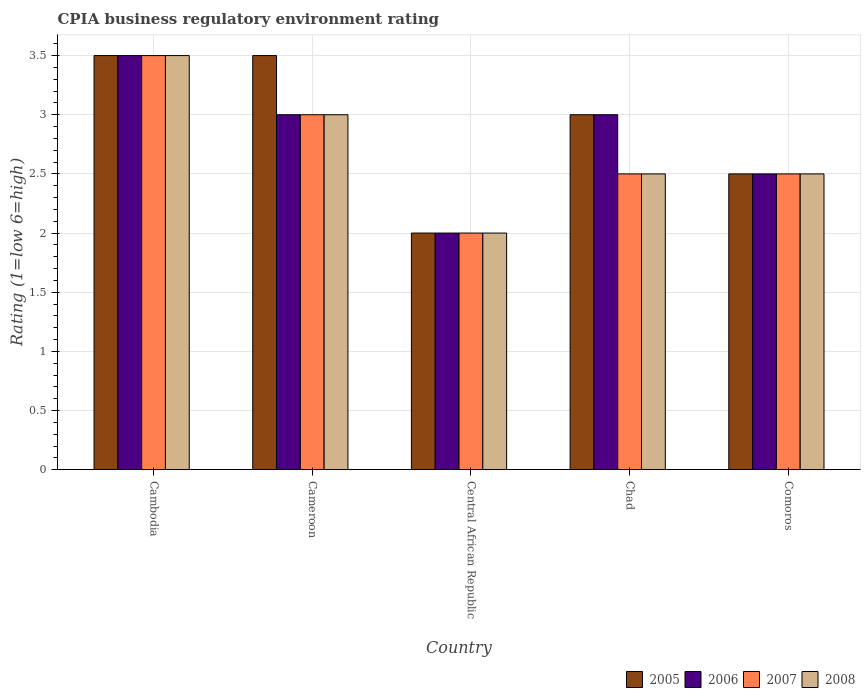How many different coloured bars are there?
Offer a terse response. 4. What is the label of the 4th group of bars from the left?
Your answer should be very brief. Chad. In which country was the CPIA rating in 2008 maximum?
Keep it short and to the point. Cambodia. In which country was the CPIA rating in 2008 minimum?
Keep it short and to the point. Central African Republic. What is the difference between the CPIA rating in 2006 in Cambodia and the CPIA rating in 2008 in Cameroon?
Keep it short and to the point. 0.5. What is the difference between the CPIA rating of/in 2007 and CPIA rating of/in 2005 in Cameroon?
Provide a succinct answer. -0.5. What is the ratio of the CPIA rating in 2007 in Cambodia to that in Central African Republic?
Your answer should be compact. 1.75. Is the CPIA rating in 2006 in Cambodia less than that in Chad?
Offer a very short reply. No. Is the difference between the CPIA rating in 2007 in Cameroon and Comoros greater than the difference between the CPIA rating in 2005 in Cameroon and Comoros?
Keep it short and to the point. No. What is the difference between the highest and the second highest CPIA rating in 2005?
Provide a succinct answer. -0.5. What is the difference between the highest and the lowest CPIA rating in 2007?
Your response must be concise. 1.5. In how many countries, is the CPIA rating in 2007 greater than the average CPIA rating in 2007 taken over all countries?
Provide a succinct answer. 2. Is the sum of the CPIA rating in 2008 in Cambodia and Central African Republic greater than the maximum CPIA rating in 2005 across all countries?
Give a very brief answer. Yes. Is it the case that in every country, the sum of the CPIA rating in 2005 and CPIA rating in 2007 is greater than the sum of CPIA rating in 2006 and CPIA rating in 2008?
Ensure brevity in your answer.  No. What does the 2nd bar from the left in Central African Republic represents?
Your answer should be compact. 2006. What does the 4th bar from the right in Cameroon represents?
Your response must be concise. 2005. Is it the case that in every country, the sum of the CPIA rating in 2007 and CPIA rating in 2008 is greater than the CPIA rating in 2006?
Keep it short and to the point. Yes. Are all the bars in the graph horizontal?
Ensure brevity in your answer.  No. What is the difference between two consecutive major ticks on the Y-axis?
Offer a terse response. 0.5. Are the values on the major ticks of Y-axis written in scientific E-notation?
Make the answer very short. No. Does the graph contain grids?
Offer a very short reply. Yes. Where does the legend appear in the graph?
Your answer should be very brief. Bottom right. How many legend labels are there?
Give a very brief answer. 4. How are the legend labels stacked?
Make the answer very short. Horizontal. What is the title of the graph?
Provide a short and direct response. CPIA business regulatory environment rating. Does "1996" appear as one of the legend labels in the graph?
Ensure brevity in your answer.  No. What is the label or title of the X-axis?
Give a very brief answer. Country. What is the label or title of the Y-axis?
Ensure brevity in your answer.  Rating (1=low 6=high). What is the Rating (1=low 6=high) of 2006 in Cameroon?
Your answer should be compact. 3. What is the Rating (1=low 6=high) in 2007 in Cameroon?
Provide a short and direct response. 3. What is the Rating (1=low 6=high) of 2007 in Central African Republic?
Your answer should be very brief. 2. What is the Rating (1=low 6=high) of 2008 in Central African Republic?
Provide a short and direct response. 2. What is the Rating (1=low 6=high) of 2005 in Chad?
Your response must be concise. 3. What is the Rating (1=low 6=high) in 2008 in Chad?
Provide a succinct answer. 2.5. What is the Rating (1=low 6=high) of 2006 in Comoros?
Provide a short and direct response. 2.5. What is the Rating (1=low 6=high) of 2007 in Comoros?
Offer a very short reply. 2.5. Across all countries, what is the minimum Rating (1=low 6=high) of 2005?
Your response must be concise. 2. What is the total Rating (1=low 6=high) of 2005 in the graph?
Give a very brief answer. 14.5. What is the total Rating (1=low 6=high) in 2006 in the graph?
Offer a very short reply. 14. What is the total Rating (1=low 6=high) of 2008 in the graph?
Make the answer very short. 13.5. What is the difference between the Rating (1=low 6=high) of 2005 in Cambodia and that in Cameroon?
Provide a succinct answer. 0. What is the difference between the Rating (1=low 6=high) in 2008 in Cambodia and that in Cameroon?
Keep it short and to the point. 0.5. What is the difference between the Rating (1=low 6=high) of 2005 in Cambodia and that in Central African Republic?
Offer a terse response. 1.5. What is the difference between the Rating (1=low 6=high) of 2007 in Cambodia and that in Central African Republic?
Offer a terse response. 1.5. What is the difference between the Rating (1=low 6=high) of 2008 in Cambodia and that in Central African Republic?
Give a very brief answer. 1.5. What is the difference between the Rating (1=low 6=high) of 2005 in Cambodia and that in Chad?
Provide a succinct answer. 0.5. What is the difference between the Rating (1=low 6=high) in 2006 in Cambodia and that in Chad?
Make the answer very short. 0.5. What is the difference between the Rating (1=low 6=high) of 2008 in Cambodia and that in Chad?
Give a very brief answer. 1. What is the difference between the Rating (1=low 6=high) in 2005 in Cambodia and that in Comoros?
Your answer should be compact. 1. What is the difference between the Rating (1=low 6=high) of 2006 in Cambodia and that in Comoros?
Ensure brevity in your answer.  1. What is the difference between the Rating (1=low 6=high) of 2007 in Cambodia and that in Comoros?
Your answer should be compact. 1. What is the difference between the Rating (1=low 6=high) in 2008 in Cambodia and that in Comoros?
Make the answer very short. 1. What is the difference between the Rating (1=low 6=high) of 2006 in Cameroon and that in Central African Republic?
Make the answer very short. 1. What is the difference between the Rating (1=low 6=high) of 2005 in Cameroon and that in Chad?
Offer a very short reply. 0.5. What is the difference between the Rating (1=low 6=high) of 2007 in Cameroon and that in Chad?
Make the answer very short. 0.5. What is the difference between the Rating (1=low 6=high) in 2008 in Cameroon and that in Chad?
Ensure brevity in your answer.  0.5. What is the difference between the Rating (1=low 6=high) of 2006 in Cameroon and that in Comoros?
Provide a short and direct response. 0.5. What is the difference between the Rating (1=low 6=high) of 2007 in Cameroon and that in Comoros?
Your response must be concise. 0.5. What is the difference between the Rating (1=low 6=high) in 2006 in Central African Republic and that in Chad?
Your answer should be compact. -1. What is the difference between the Rating (1=low 6=high) of 2007 in Central African Republic and that in Chad?
Give a very brief answer. -0.5. What is the difference between the Rating (1=low 6=high) of 2005 in Central African Republic and that in Comoros?
Your response must be concise. -0.5. What is the difference between the Rating (1=low 6=high) in 2008 in Central African Republic and that in Comoros?
Your response must be concise. -0.5. What is the difference between the Rating (1=low 6=high) in 2005 in Chad and that in Comoros?
Make the answer very short. 0.5. What is the difference between the Rating (1=low 6=high) in 2008 in Chad and that in Comoros?
Offer a very short reply. 0. What is the difference between the Rating (1=low 6=high) in 2005 in Cambodia and the Rating (1=low 6=high) in 2007 in Cameroon?
Offer a terse response. 0.5. What is the difference between the Rating (1=low 6=high) of 2006 in Cambodia and the Rating (1=low 6=high) of 2007 in Cameroon?
Provide a succinct answer. 0.5. What is the difference between the Rating (1=low 6=high) of 2007 in Cambodia and the Rating (1=low 6=high) of 2008 in Cameroon?
Your response must be concise. 0.5. What is the difference between the Rating (1=low 6=high) in 2005 in Cambodia and the Rating (1=low 6=high) in 2006 in Central African Republic?
Offer a terse response. 1.5. What is the difference between the Rating (1=low 6=high) in 2005 in Cambodia and the Rating (1=low 6=high) in 2008 in Central African Republic?
Make the answer very short. 1.5. What is the difference between the Rating (1=low 6=high) in 2007 in Cambodia and the Rating (1=low 6=high) in 2008 in Central African Republic?
Offer a very short reply. 1.5. What is the difference between the Rating (1=low 6=high) in 2005 in Cambodia and the Rating (1=low 6=high) in 2008 in Chad?
Offer a very short reply. 1. What is the difference between the Rating (1=low 6=high) of 2006 in Cambodia and the Rating (1=low 6=high) of 2007 in Chad?
Offer a very short reply. 1. What is the difference between the Rating (1=low 6=high) of 2007 in Cambodia and the Rating (1=low 6=high) of 2008 in Chad?
Provide a short and direct response. 1. What is the difference between the Rating (1=low 6=high) in 2005 in Cambodia and the Rating (1=low 6=high) in 2007 in Comoros?
Keep it short and to the point. 1. What is the difference between the Rating (1=low 6=high) of 2006 in Cambodia and the Rating (1=low 6=high) of 2007 in Comoros?
Make the answer very short. 1. What is the difference between the Rating (1=low 6=high) in 2006 in Cameroon and the Rating (1=low 6=high) in 2008 in Central African Republic?
Your answer should be very brief. 1. What is the difference between the Rating (1=low 6=high) of 2005 in Cameroon and the Rating (1=low 6=high) of 2006 in Chad?
Your answer should be compact. 0.5. What is the difference between the Rating (1=low 6=high) of 2005 in Cameroon and the Rating (1=low 6=high) of 2007 in Chad?
Your answer should be very brief. 1. What is the difference between the Rating (1=low 6=high) in 2007 in Cameroon and the Rating (1=low 6=high) in 2008 in Chad?
Offer a terse response. 0.5. What is the difference between the Rating (1=low 6=high) in 2005 in Cameroon and the Rating (1=low 6=high) in 2006 in Comoros?
Your answer should be very brief. 1. What is the difference between the Rating (1=low 6=high) in 2005 in Cameroon and the Rating (1=low 6=high) in 2007 in Comoros?
Offer a very short reply. 1. What is the difference between the Rating (1=low 6=high) in 2005 in Cameroon and the Rating (1=low 6=high) in 2008 in Comoros?
Keep it short and to the point. 1. What is the difference between the Rating (1=low 6=high) of 2006 in Cameroon and the Rating (1=low 6=high) of 2007 in Comoros?
Offer a terse response. 0.5. What is the difference between the Rating (1=low 6=high) of 2006 in Cameroon and the Rating (1=low 6=high) of 2008 in Comoros?
Your answer should be compact. 0.5. What is the difference between the Rating (1=low 6=high) in 2005 in Central African Republic and the Rating (1=low 6=high) in 2007 in Chad?
Offer a very short reply. -0.5. What is the difference between the Rating (1=low 6=high) in 2005 in Central African Republic and the Rating (1=low 6=high) in 2008 in Chad?
Give a very brief answer. -0.5. What is the difference between the Rating (1=low 6=high) of 2007 in Central African Republic and the Rating (1=low 6=high) of 2008 in Chad?
Offer a very short reply. -0.5. What is the difference between the Rating (1=low 6=high) of 2005 in Central African Republic and the Rating (1=low 6=high) of 2006 in Comoros?
Offer a terse response. -0.5. What is the difference between the Rating (1=low 6=high) in 2005 in Central African Republic and the Rating (1=low 6=high) in 2008 in Comoros?
Your answer should be very brief. -0.5. What is the difference between the Rating (1=low 6=high) in 2006 in Central African Republic and the Rating (1=low 6=high) in 2008 in Comoros?
Provide a short and direct response. -0.5. What is the difference between the Rating (1=low 6=high) of 2007 in Central African Republic and the Rating (1=low 6=high) of 2008 in Comoros?
Offer a terse response. -0.5. What is the average Rating (1=low 6=high) of 2005 per country?
Make the answer very short. 2.9. What is the average Rating (1=low 6=high) in 2006 per country?
Make the answer very short. 2.8. What is the difference between the Rating (1=low 6=high) of 2005 and Rating (1=low 6=high) of 2006 in Cambodia?
Make the answer very short. 0. What is the difference between the Rating (1=low 6=high) in 2005 and Rating (1=low 6=high) in 2007 in Cambodia?
Keep it short and to the point. 0. What is the difference between the Rating (1=low 6=high) in 2005 and Rating (1=low 6=high) in 2008 in Cambodia?
Offer a very short reply. 0. What is the difference between the Rating (1=low 6=high) of 2006 and Rating (1=low 6=high) of 2007 in Cambodia?
Offer a terse response. 0. What is the difference between the Rating (1=low 6=high) of 2006 and Rating (1=low 6=high) of 2008 in Cambodia?
Provide a short and direct response. 0. What is the difference between the Rating (1=low 6=high) in 2005 and Rating (1=low 6=high) in 2006 in Cameroon?
Make the answer very short. 0.5. What is the difference between the Rating (1=low 6=high) in 2005 and Rating (1=low 6=high) in 2007 in Cameroon?
Your response must be concise. 0.5. What is the difference between the Rating (1=low 6=high) in 2006 and Rating (1=low 6=high) in 2008 in Cameroon?
Provide a short and direct response. 0. What is the difference between the Rating (1=low 6=high) of 2007 and Rating (1=low 6=high) of 2008 in Cameroon?
Make the answer very short. 0. What is the difference between the Rating (1=low 6=high) in 2005 and Rating (1=low 6=high) in 2006 in Central African Republic?
Offer a terse response. 0. What is the difference between the Rating (1=low 6=high) in 2005 and Rating (1=low 6=high) in 2008 in Central African Republic?
Your answer should be very brief. 0. What is the difference between the Rating (1=low 6=high) in 2006 and Rating (1=low 6=high) in 2008 in Central African Republic?
Provide a short and direct response. 0. What is the difference between the Rating (1=low 6=high) of 2005 and Rating (1=low 6=high) of 2008 in Chad?
Ensure brevity in your answer.  0.5. What is the difference between the Rating (1=low 6=high) of 2006 and Rating (1=low 6=high) of 2008 in Chad?
Provide a short and direct response. 0.5. What is the difference between the Rating (1=low 6=high) in 2007 and Rating (1=low 6=high) in 2008 in Chad?
Offer a very short reply. 0. What is the difference between the Rating (1=low 6=high) in 2005 and Rating (1=low 6=high) in 2006 in Comoros?
Offer a very short reply. 0. What is the difference between the Rating (1=low 6=high) of 2005 and Rating (1=low 6=high) of 2007 in Comoros?
Your answer should be compact. 0. What is the difference between the Rating (1=low 6=high) of 2007 and Rating (1=low 6=high) of 2008 in Comoros?
Ensure brevity in your answer.  0. What is the ratio of the Rating (1=low 6=high) of 2006 in Cambodia to that in Cameroon?
Your answer should be compact. 1.17. What is the ratio of the Rating (1=low 6=high) in 2008 in Cambodia to that in Cameroon?
Give a very brief answer. 1.17. What is the ratio of the Rating (1=low 6=high) in 2006 in Cambodia to that in Chad?
Your answer should be compact. 1.17. What is the ratio of the Rating (1=low 6=high) in 2005 in Cambodia to that in Comoros?
Offer a very short reply. 1.4. What is the ratio of the Rating (1=low 6=high) of 2007 in Cambodia to that in Comoros?
Provide a succinct answer. 1.4. What is the ratio of the Rating (1=low 6=high) in 2008 in Cambodia to that in Comoros?
Keep it short and to the point. 1.4. What is the ratio of the Rating (1=low 6=high) in 2005 in Cameroon to that in Central African Republic?
Offer a terse response. 1.75. What is the ratio of the Rating (1=low 6=high) of 2006 in Cameroon to that in Central African Republic?
Give a very brief answer. 1.5. What is the ratio of the Rating (1=low 6=high) of 2005 in Cameroon to that in Chad?
Ensure brevity in your answer.  1.17. What is the ratio of the Rating (1=low 6=high) of 2007 in Cameroon to that in Chad?
Keep it short and to the point. 1.2. What is the ratio of the Rating (1=low 6=high) of 2005 in Cameroon to that in Comoros?
Offer a terse response. 1.4. What is the ratio of the Rating (1=low 6=high) in 2006 in Cameroon to that in Comoros?
Offer a very short reply. 1.2. What is the ratio of the Rating (1=low 6=high) in 2008 in Cameroon to that in Comoros?
Provide a succinct answer. 1.2. What is the ratio of the Rating (1=low 6=high) of 2005 in Central African Republic to that in Chad?
Give a very brief answer. 0.67. What is the ratio of the Rating (1=low 6=high) of 2007 in Central African Republic to that in Chad?
Give a very brief answer. 0.8. What is the ratio of the Rating (1=low 6=high) in 2006 in Central African Republic to that in Comoros?
Provide a succinct answer. 0.8. What is the ratio of the Rating (1=low 6=high) of 2008 in Central African Republic to that in Comoros?
Make the answer very short. 0.8. What is the ratio of the Rating (1=low 6=high) of 2006 in Chad to that in Comoros?
Your answer should be very brief. 1.2. What is the ratio of the Rating (1=low 6=high) in 2008 in Chad to that in Comoros?
Offer a terse response. 1. What is the difference between the highest and the second highest Rating (1=low 6=high) in 2006?
Your answer should be very brief. 0.5. What is the difference between the highest and the lowest Rating (1=low 6=high) in 2005?
Offer a terse response. 1.5. 